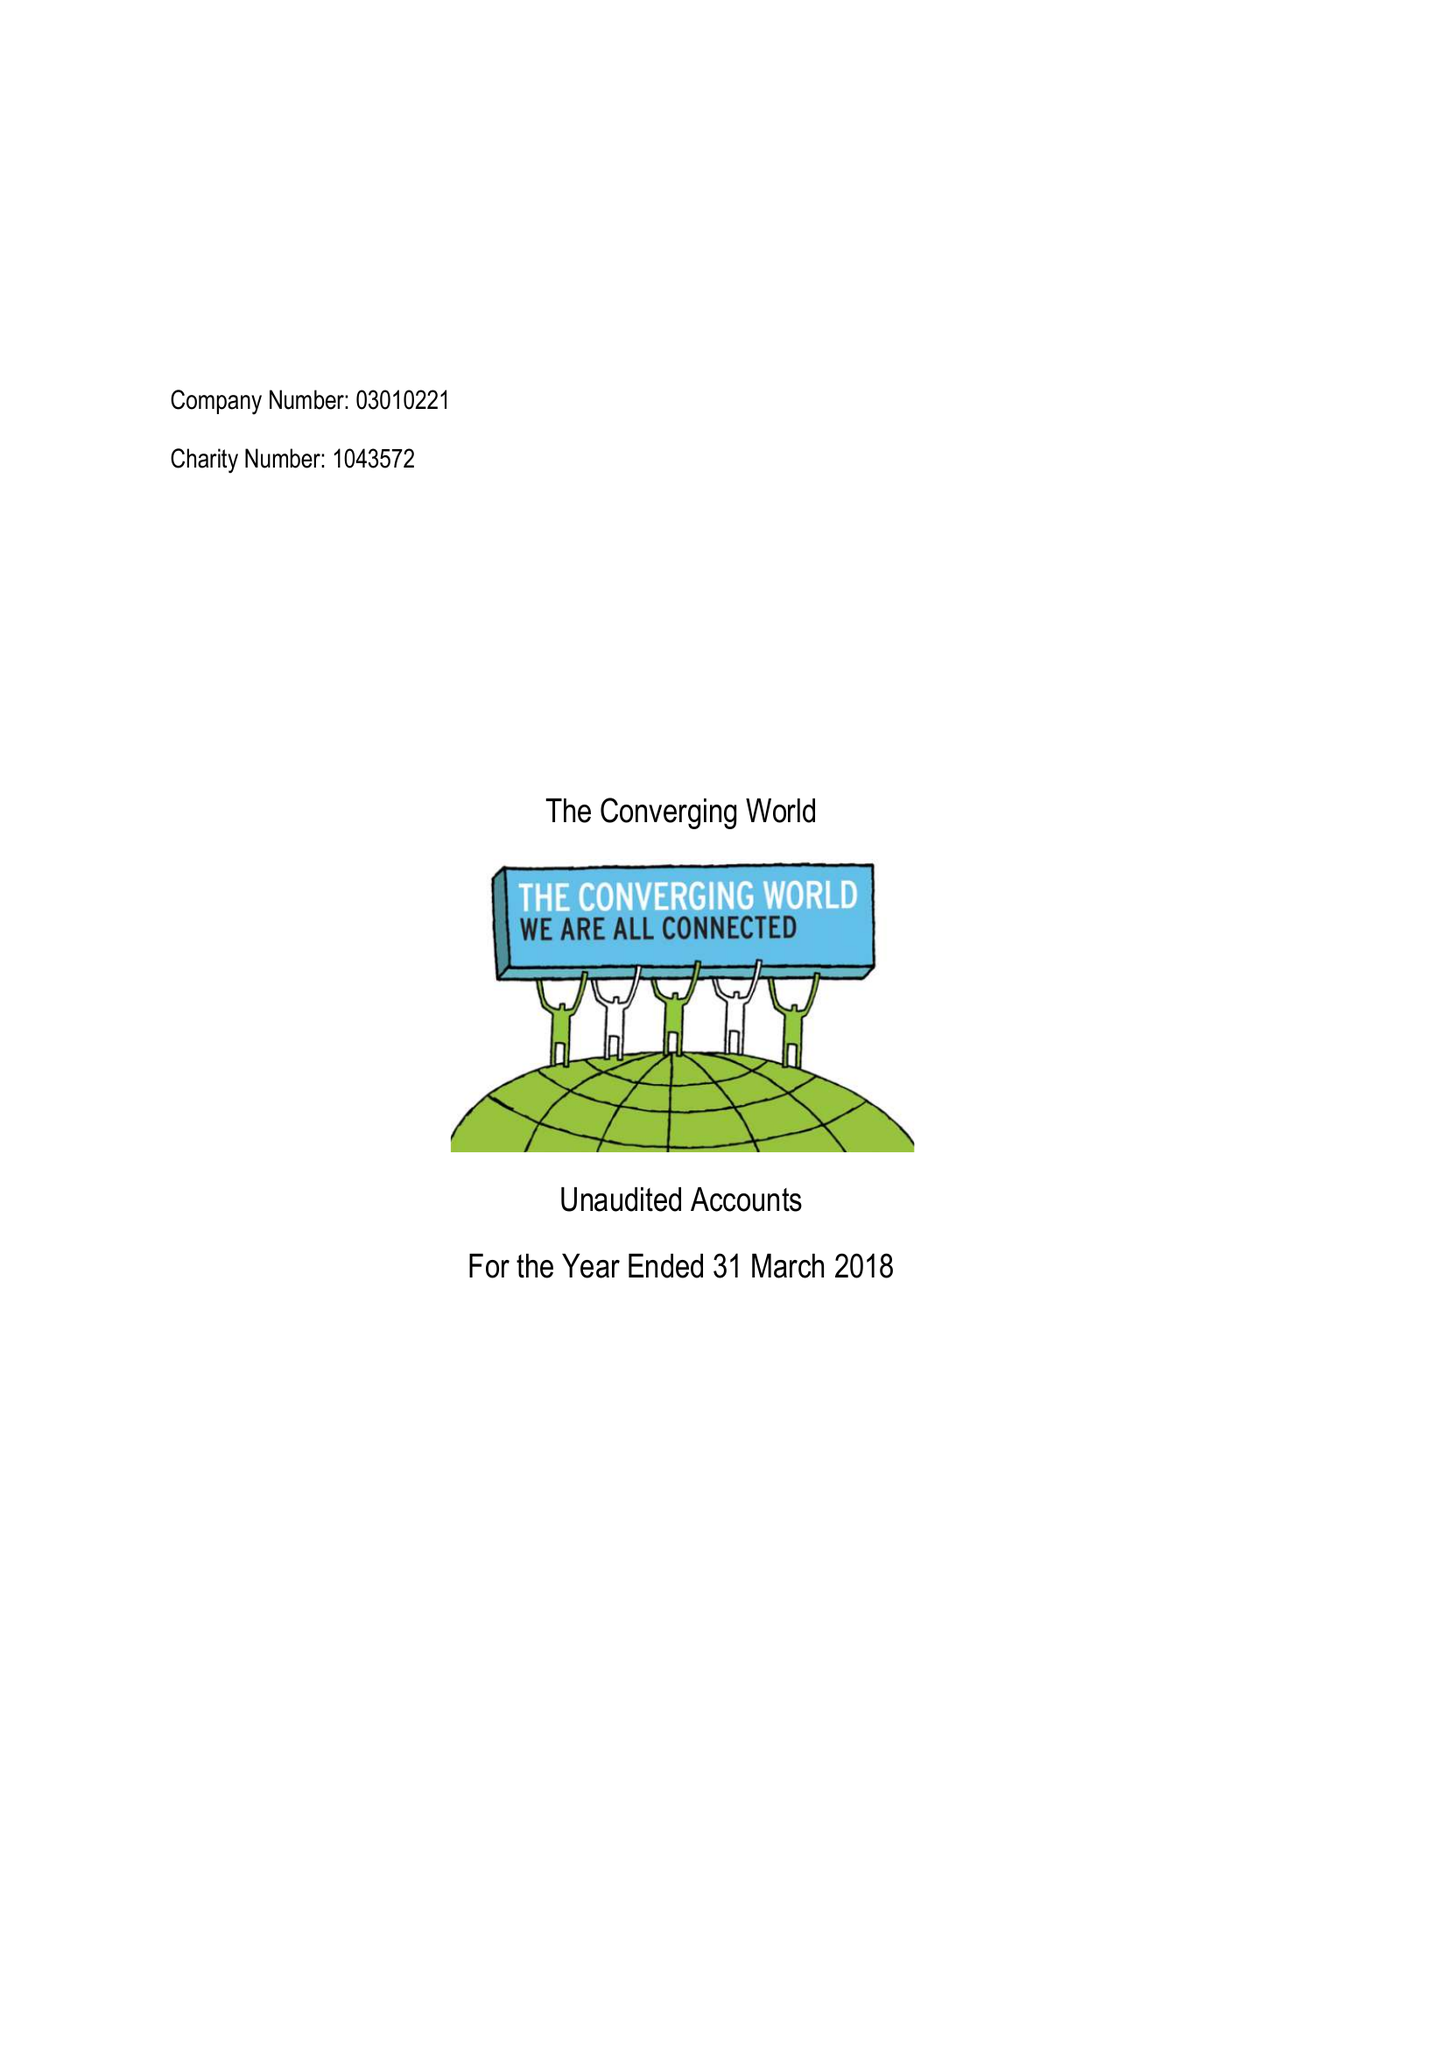What is the value for the address__street_line?
Answer the question using a single word or phrase. 30 QUEEN CHARLOTTE STREET 